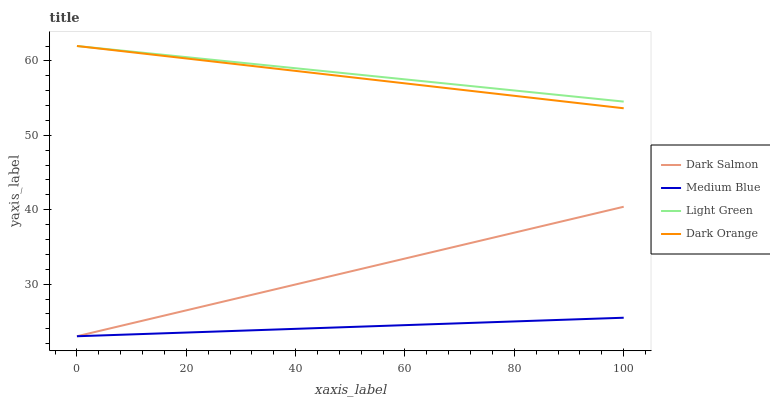Does Medium Blue have the minimum area under the curve?
Answer yes or no. Yes. Does Light Green have the maximum area under the curve?
Answer yes or no. Yes. Does Dark Salmon have the minimum area under the curve?
Answer yes or no. No. Does Dark Salmon have the maximum area under the curve?
Answer yes or no. No. Is Medium Blue the smoothest?
Answer yes or no. Yes. Is Dark Orange the roughest?
Answer yes or no. Yes. Is Dark Salmon the smoothest?
Answer yes or no. No. Is Dark Salmon the roughest?
Answer yes or no. No. Does Medium Blue have the lowest value?
Answer yes or no. Yes. Does Light Green have the lowest value?
Answer yes or no. No. Does Light Green have the highest value?
Answer yes or no. Yes. Does Dark Salmon have the highest value?
Answer yes or no. No. Is Dark Salmon less than Dark Orange?
Answer yes or no. Yes. Is Dark Orange greater than Dark Salmon?
Answer yes or no. Yes. Does Dark Orange intersect Light Green?
Answer yes or no. Yes. Is Dark Orange less than Light Green?
Answer yes or no. No. Is Dark Orange greater than Light Green?
Answer yes or no. No. Does Dark Salmon intersect Dark Orange?
Answer yes or no. No. 